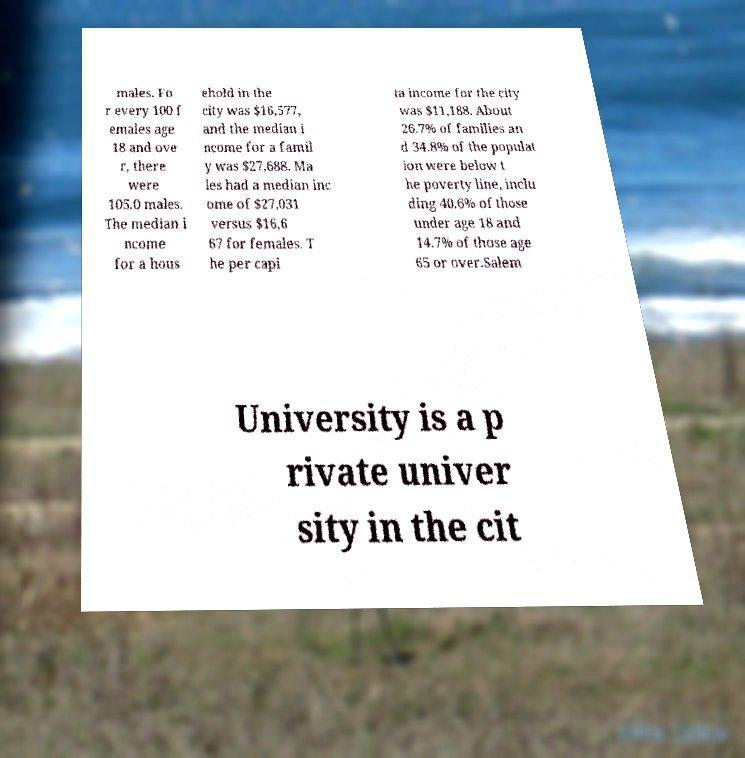For documentation purposes, I need the text within this image transcribed. Could you provide that? males. Fo r every 100 f emales age 18 and ove r, there were 105.0 males. The median i ncome for a hous ehold in the city was $16,577, and the median i ncome for a famil y was $27,688. Ma les had a median inc ome of $27,031 versus $16,6 67 for females. T he per capi ta income for the city was $11,188. About 26.7% of families an d 34.8% of the populat ion were below t he poverty line, inclu ding 40.6% of those under age 18 and 14.7% of those age 65 or over.Salem University is a p rivate univer sity in the cit 